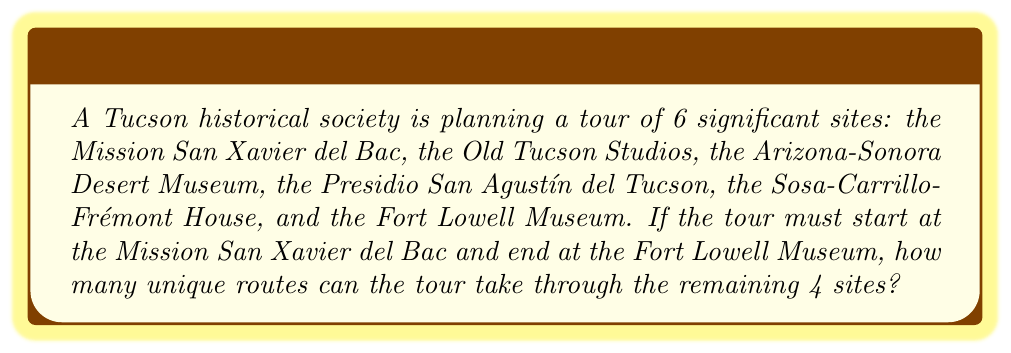Solve this math problem. Let's approach this step-by-step:

1) The tour has a fixed starting point (Mission San Xavier del Bac) and a fixed ending point (Fort Lowell Museum). This means we only need to arrange the order of the 4 remaining sites.

2) Arranging 4 sites in different orders is a permutation problem. The formula for permutations of n distinct objects is:

   $$P(n) = n!$$

3) In this case, n = 4, so we calculate:

   $$P(4) = 4!$$

4) Let's expand this:
   
   $$4! = 4 \times 3 \times 2 \times 1 = 24$$

Therefore, there are 24 unique ways to arrange the 4 middle sites of the tour.
Answer: 24 